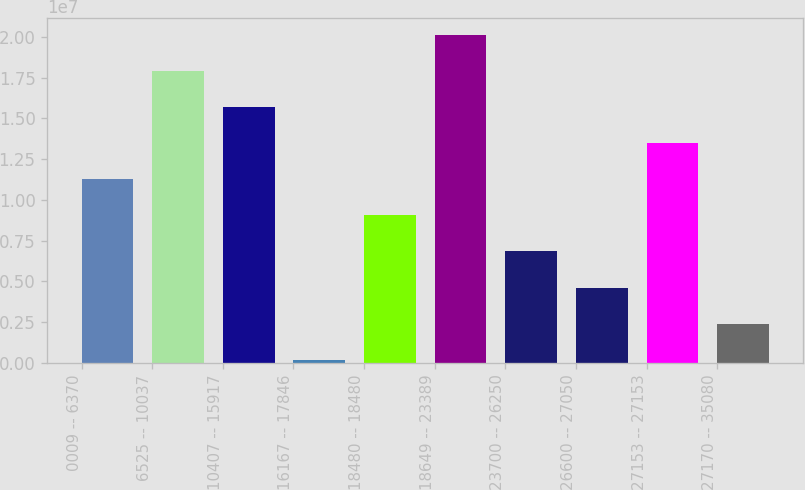Convert chart to OTSL. <chart><loc_0><loc_0><loc_500><loc_500><bar_chart><fcel>0009 -- 6370<fcel>6525 -- 10037<fcel>10407 -- 15917<fcel>16167 -- 17846<fcel>18480 -- 18480<fcel>18649 -- 23389<fcel>23700 -- 26250<fcel>26600 -- 27050<fcel>27153 -- 27153<fcel>27170 -- 35080<nl><fcel>1.12814e+07<fcel>1.7935e+07<fcel>1.57171e+07<fcel>192097<fcel>9.06353e+06<fcel>2.01528e+07<fcel>6.84567e+06<fcel>4.62781e+06<fcel>1.34993e+07<fcel>2.40996e+06<nl></chart> 